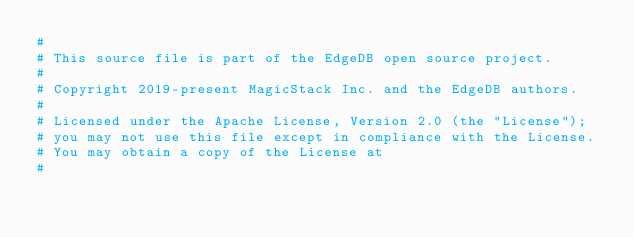Convert code to text. <code><loc_0><loc_0><loc_500><loc_500><_Cython_>#
# This source file is part of the EdgeDB open source project.
#
# Copyright 2019-present MagicStack Inc. and the EdgeDB authors.
#
# Licensed under the Apache License, Version 2.0 (the "License");
# you may not use this file except in compliance with the License.
# You may obtain a copy of the License at
#</code> 